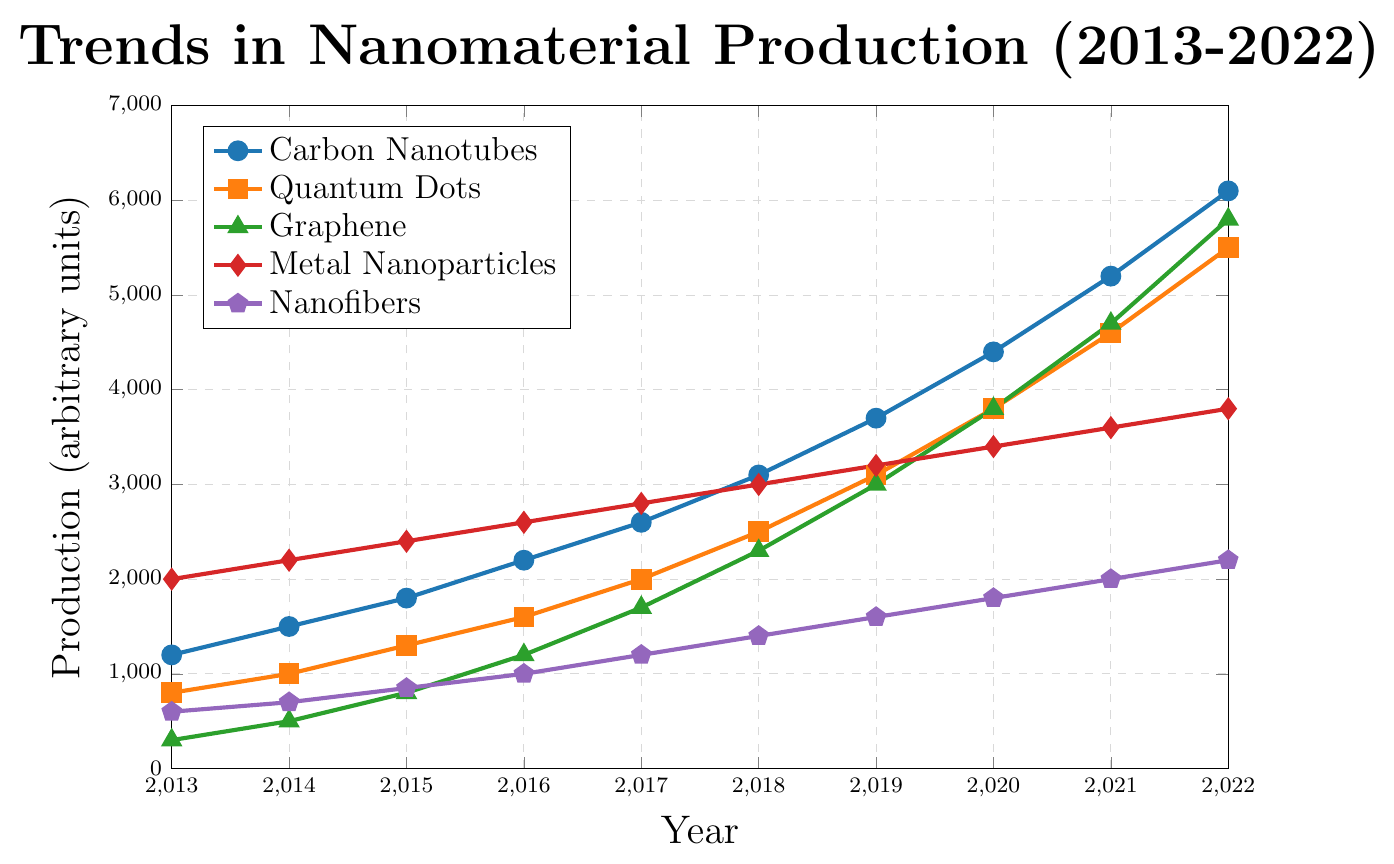What is the production trend for Carbon Nanotubes between 2013 and 2022? From the chart, observe the line representing Carbon Nanotubes, which shows a consistent increase from 1200 units in 2013 to 6100 units in 2022.
Answer: Consistent increase Which nanomaterial had the highest production in 2022? Look at the endpoint of each line on the chart for 2022. The line for Carbon Nanotubes ends at 6100 units, which is the highest value among all the nanomaterials.
Answer: Carbon Nanotubes How much did Quantum Dots' production increase from 2013 to 2022? Subtract the 2013 production value (800 units) from the 2022 production value (5500 units). The increase is 5500 - 800 = 4700 units.
Answer: 4700 units Which nanomaterial had the lowest production in 2015? Compare the production values of all the nanomaterials in 2015. The lowest value is for Graphene at 800 units.
Answer: Graphene How does the production trend of Metal Nanoparticles compare to Nanofibers? Observe both lines on the chart. Metal Nanoparticles consistently have higher production values than Nanofibers, although both increase over time.
Answer: Metal Nanoparticles have higher production What is the average annual production increase for Graphene from 2013 to 2022? Find the production increase for Graphene from 300 units in 2013 to 5800 units in 2022, which is 5800 - 300 = 5500 units. Divide this by the number of years (9 years). 5500/9 ≈ 611.11 units per year.
Answer: Approximately 611.11 units per year Which nanomaterial showed the greatest increase in production between 2017 and 2018? Compare the increase for each material between 2017 and 2018. For Carbon Nanotubes = 3100 - 2600 = 500 units, Quantum Dots = 2500 - 2000 = 500 units, Graphene = 2300 - 1700 = 600 units, Metal Nanoparticles = 3000 - 2800 = 200 units, Nanofibers = 1400 - 1200 = 200 units. Graphene has the greatest increase of 600 units.
Answer: Graphene What was the total production of all nanomaterials in 2016? Sum the 2016 production values for all materials: 2200 (Carbon Nanotubes) + 1600 (Quantum Dots) + 1200 (Graphene) + 2600 (Metal Nanoparticles) + 1000 (Nanofibers) = 8600 units.
Answer: 8600 units Which nanomaterial had the steepest rise in production rate after 2018? Identify the slope of each material's line after 2018. Carbon Nanotubes increase from 3100 to 6100 (steep rise), Quantum Dots from 2500 to 5500, Graphene from 2300 to 5800 (steep rise), Metal Nanoparticles from 3000 to 3800, and Nanofibers from 1400 to 2200. Both Carbon Nanotubes and Graphene show steep rises, with Graphene having a steeper and sharper increase.
Answer: Graphene 